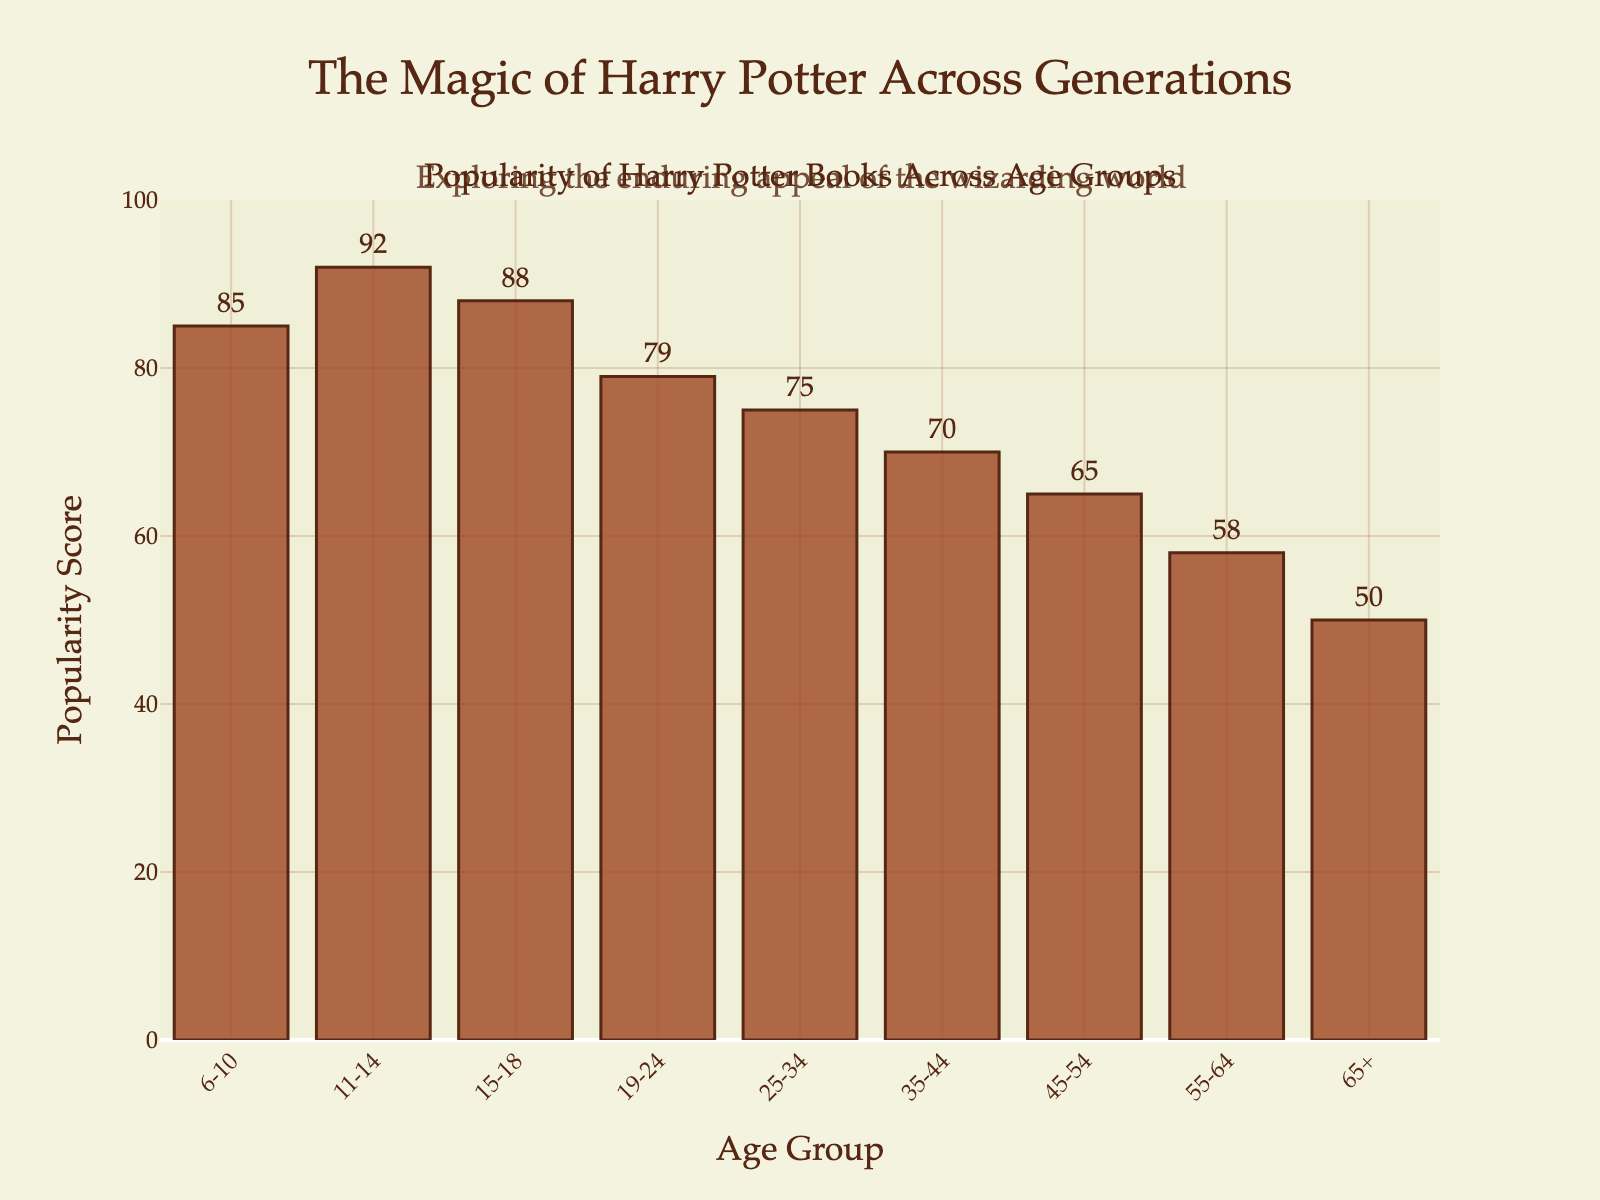What age group has the highest popularity score? The bar for the 11-14 age group is the tallest, indicating it has the highest popularity score.
Answer: 11-14 Which age group shows the lowest popularity score? The bar for the 65+ age group is the shortest, indicating it has the lowest popularity score.
Answer: 65+ What is the difference in popularity scores between the age groups 15-18 and 19-24? The popularity score for the 15-18 age group is 88, and for the 19-24 age group, it is 79. Subtracting 79 from 88 gives 9.
Answer: 9 What is the average popularity score for the age groups 45-54, 55-64, and 65+? The popularity scores for the age groups 45-54, 55-64, and 65+ are 65, 58, and 50, respectively. Adding these values (65 + 58 + 50 = 173) and dividing by the number of age groups (3) gives 173 / 3 ≈ 57.67.
Answer: 57.67 Which age groups have a popularity score greater than 80? The age groups with popularity scores greater than 80 are 6-10, 11-14, and 15-18, as their bars are above the 80 mark on the y-axis.
Answer: 6-10, 11-14, 15-18 How many age groups have a popularity score of 70 or higher? The age groups that have scores of 70 or higher are 6-10, 11-14, 15-18, 19-24, 25-34, and 35-44. Counting these age groups gives 6.
Answer: 6 By how much does the popularity score of the 11-14 age group exceed that of the 45-54 age group? The popularity score for the 11-14 age group is 92, and for the 45-54 age group, it is 65. Subtracting 65 from 92 gives 27.
Answer: 27 Which age group has a popularity score closest to 75? The age groups 25-34 has a popularity score of 75, which is exactly 75.
Answer: 25-34 Is the popularity score of the age group 35-44 more than or less than half of the popularity score of the age group 11-14? The popularity score for the 11-14 age group is 92, and half of 92 is 46. The popularity score for the 35-44 age group is 70, which is more than 46.
Answer: More 